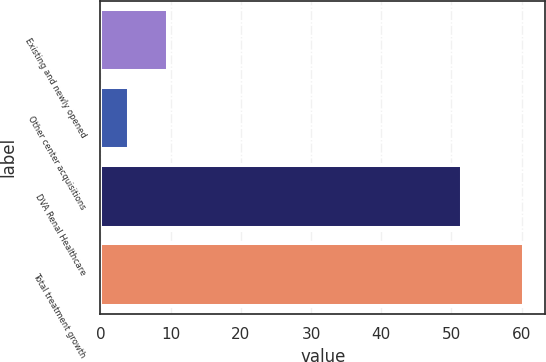Convert chart to OTSL. <chart><loc_0><loc_0><loc_500><loc_500><bar_chart><fcel>Existing and newly opened<fcel>Other center acquisitions<fcel>DVA Renal Healthcare<fcel>Total treatment growth<nl><fcel>9.63<fcel>4<fcel>51.5<fcel>60.3<nl></chart> 